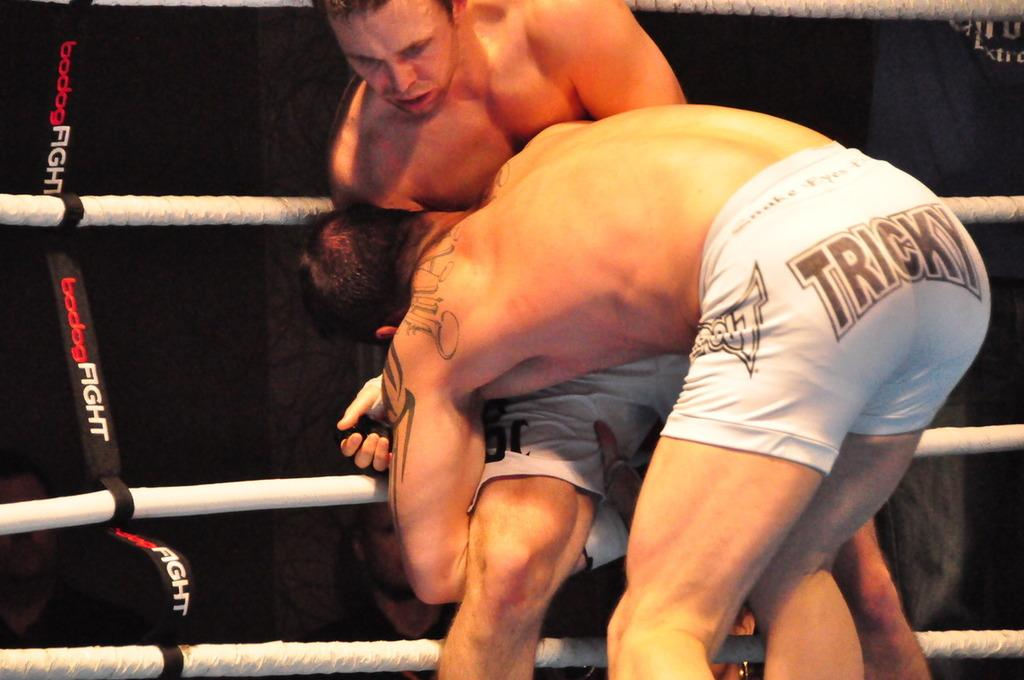<image>
Create a compact narrative representing the image presented. Two bovers fight in a ring one of whom is wearing white shorts with Tricky written on them. 